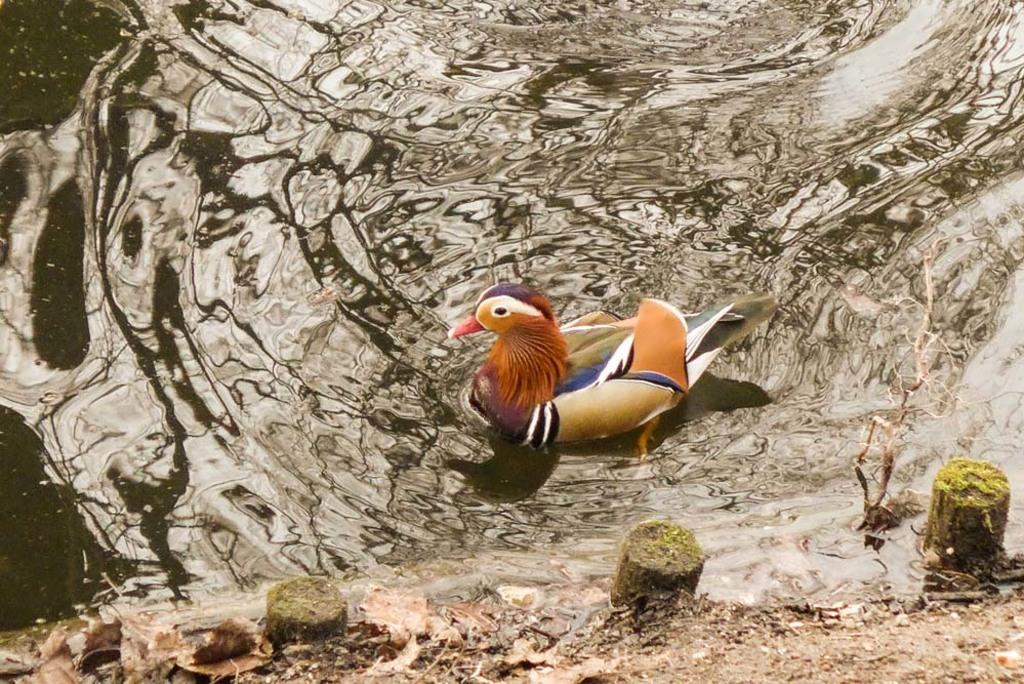What animal is present in the image? There is a duck in the image. Where is the duck located? The duck is in the water. What type of hammer is the duck using to fix the truck in the image? There is no hammer or truck present in the image; it only features a duck in the water. 